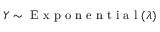<formula> <loc_0><loc_0><loc_500><loc_500>Y \sim { E x p o n e n t i a l } ( \lambda )</formula> 